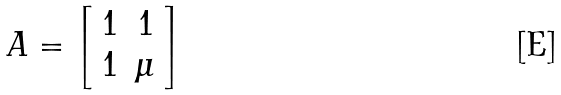Convert formula to latex. <formula><loc_0><loc_0><loc_500><loc_500>A = \left [ \begin{array} { r r } 1 & 1 \\ 1 & \mu \end{array} \right ]</formula> 